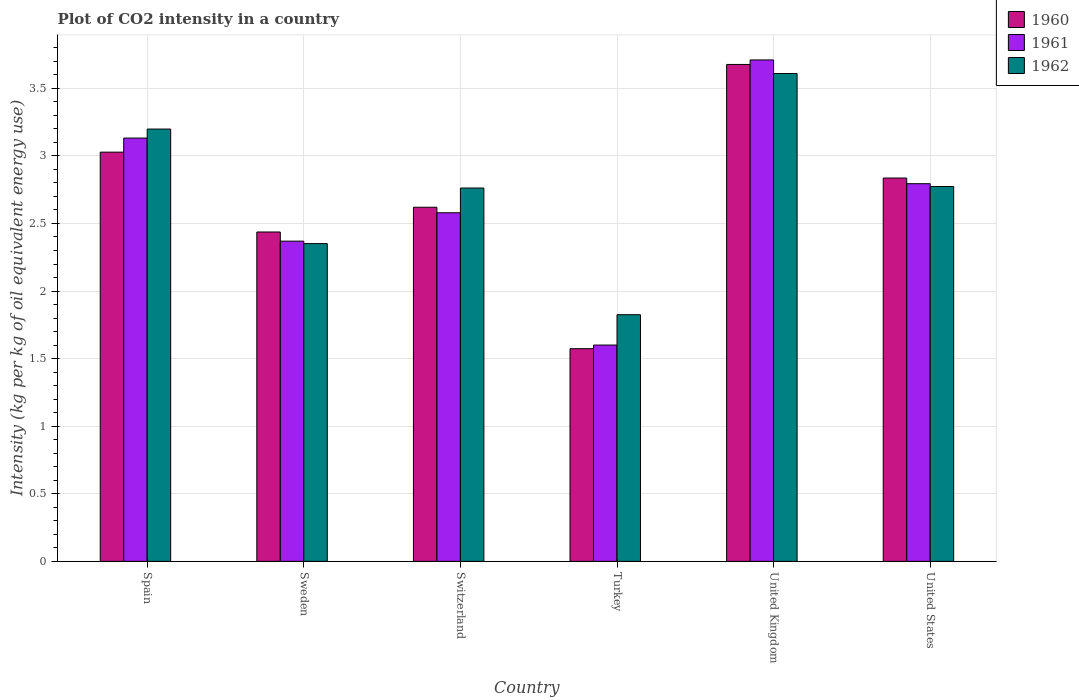How many bars are there on the 1st tick from the left?
Give a very brief answer. 3. What is the CO2 intensity in in 1961 in Spain?
Make the answer very short. 3.13. Across all countries, what is the maximum CO2 intensity in in 1960?
Give a very brief answer. 3.68. Across all countries, what is the minimum CO2 intensity in in 1960?
Your response must be concise. 1.57. What is the total CO2 intensity in in 1960 in the graph?
Provide a short and direct response. 16.17. What is the difference between the CO2 intensity in in 1960 in Turkey and that in United States?
Offer a terse response. -1.26. What is the difference between the CO2 intensity in in 1960 in United Kingdom and the CO2 intensity in in 1962 in Turkey?
Give a very brief answer. 1.85. What is the average CO2 intensity in in 1960 per country?
Provide a short and direct response. 2.7. What is the difference between the CO2 intensity in of/in 1961 and CO2 intensity in of/in 1960 in Sweden?
Your answer should be compact. -0.07. What is the ratio of the CO2 intensity in in 1961 in Switzerland to that in United Kingdom?
Your response must be concise. 0.7. Is the CO2 intensity in in 1960 in Sweden less than that in Turkey?
Provide a short and direct response. No. What is the difference between the highest and the second highest CO2 intensity in in 1962?
Provide a short and direct response. 0.43. What is the difference between the highest and the lowest CO2 intensity in in 1962?
Provide a succinct answer. 1.78. What does the 3rd bar from the left in Spain represents?
Give a very brief answer. 1962. What does the 2nd bar from the right in Turkey represents?
Your answer should be very brief. 1961. Is it the case that in every country, the sum of the CO2 intensity in in 1960 and CO2 intensity in in 1961 is greater than the CO2 intensity in in 1962?
Your response must be concise. Yes. How many bars are there?
Your response must be concise. 18. What is the difference between two consecutive major ticks on the Y-axis?
Give a very brief answer. 0.5. Are the values on the major ticks of Y-axis written in scientific E-notation?
Ensure brevity in your answer.  No. Does the graph contain grids?
Make the answer very short. Yes. Where does the legend appear in the graph?
Your answer should be very brief. Top right. What is the title of the graph?
Your answer should be very brief. Plot of CO2 intensity in a country. Does "2006" appear as one of the legend labels in the graph?
Provide a succinct answer. No. What is the label or title of the X-axis?
Give a very brief answer. Country. What is the label or title of the Y-axis?
Offer a terse response. Intensity (kg per kg of oil equivalent energy use). What is the Intensity (kg per kg of oil equivalent energy use) in 1960 in Spain?
Your answer should be very brief. 3.03. What is the Intensity (kg per kg of oil equivalent energy use) in 1961 in Spain?
Your response must be concise. 3.13. What is the Intensity (kg per kg of oil equivalent energy use) in 1962 in Spain?
Make the answer very short. 3.2. What is the Intensity (kg per kg of oil equivalent energy use) of 1960 in Sweden?
Make the answer very short. 2.44. What is the Intensity (kg per kg of oil equivalent energy use) in 1961 in Sweden?
Keep it short and to the point. 2.37. What is the Intensity (kg per kg of oil equivalent energy use) of 1962 in Sweden?
Make the answer very short. 2.35. What is the Intensity (kg per kg of oil equivalent energy use) in 1960 in Switzerland?
Ensure brevity in your answer.  2.62. What is the Intensity (kg per kg of oil equivalent energy use) of 1961 in Switzerland?
Your response must be concise. 2.58. What is the Intensity (kg per kg of oil equivalent energy use) of 1962 in Switzerland?
Your response must be concise. 2.76. What is the Intensity (kg per kg of oil equivalent energy use) in 1960 in Turkey?
Give a very brief answer. 1.57. What is the Intensity (kg per kg of oil equivalent energy use) in 1961 in Turkey?
Ensure brevity in your answer.  1.6. What is the Intensity (kg per kg of oil equivalent energy use) of 1962 in Turkey?
Provide a succinct answer. 1.82. What is the Intensity (kg per kg of oil equivalent energy use) of 1960 in United Kingdom?
Make the answer very short. 3.68. What is the Intensity (kg per kg of oil equivalent energy use) in 1961 in United Kingdom?
Provide a short and direct response. 3.71. What is the Intensity (kg per kg of oil equivalent energy use) of 1962 in United Kingdom?
Provide a short and direct response. 3.61. What is the Intensity (kg per kg of oil equivalent energy use) in 1960 in United States?
Provide a short and direct response. 2.84. What is the Intensity (kg per kg of oil equivalent energy use) in 1961 in United States?
Keep it short and to the point. 2.79. What is the Intensity (kg per kg of oil equivalent energy use) of 1962 in United States?
Offer a terse response. 2.77. Across all countries, what is the maximum Intensity (kg per kg of oil equivalent energy use) of 1960?
Your answer should be very brief. 3.68. Across all countries, what is the maximum Intensity (kg per kg of oil equivalent energy use) of 1961?
Your answer should be compact. 3.71. Across all countries, what is the maximum Intensity (kg per kg of oil equivalent energy use) in 1962?
Provide a short and direct response. 3.61. Across all countries, what is the minimum Intensity (kg per kg of oil equivalent energy use) of 1960?
Provide a succinct answer. 1.57. Across all countries, what is the minimum Intensity (kg per kg of oil equivalent energy use) in 1961?
Make the answer very short. 1.6. Across all countries, what is the minimum Intensity (kg per kg of oil equivalent energy use) of 1962?
Your response must be concise. 1.82. What is the total Intensity (kg per kg of oil equivalent energy use) of 1960 in the graph?
Keep it short and to the point. 16.17. What is the total Intensity (kg per kg of oil equivalent energy use) of 1961 in the graph?
Ensure brevity in your answer.  16.18. What is the total Intensity (kg per kg of oil equivalent energy use) in 1962 in the graph?
Ensure brevity in your answer.  16.52. What is the difference between the Intensity (kg per kg of oil equivalent energy use) of 1960 in Spain and that in Sweden?
Ensure brevity in your answer.  0.59. What is the difference between the Intensity (kg per kg of oil equivalent energy use) of 1961 in Spain and that in Sweden?
Your response must be concise. 0.76. What is the difference between the Intensity (kg per kg of oil equivalent energy use) in 1962 in Spain and that in Sweden?
Offer a very short reply. 0.85. What is the difference between the Intensity (kg per kg of oil equivalent energy use) in 1960 in Spain and that in Switzerland?
Your response must be concise. 0.41. What is the difference between the Intensity (kg per kg of oil equivalent energy use) in 1961 in Spain and that in Switzerland?
Your response must be concise. 0.55. What is the difference between the Intensity (kg per kg of oil equivalent energy use) in 1962 in Spain and that in Switzerland?
Your answer should be compact. 0.44. What is the difference between the Intensity (kg per kg of oil equivalent energy use) in 1960 in Spain and that in Turkey?
Your answer should be very brief. 1.45. What is the difference between the Intensity (kg per kg of oil equivalent energy use) of 1961 in Spain and that in Turkey?
Keep it short and to the point. 1.53. What is the difference between the Intensity (kg per kg of oil equivalent energy use) of 1962 in Spain and that in Turkey?
Your answer should be compact. 1.37. What is the difference between the Intensity (kg per kg of oil equivalent energy use) in 1960 in Spain and that in United Kingdom?
Offer a terse response. -0.65. What is the difference between the Intensity (kg per kg of oil equivalent energy use) of 1961 in Spain and that in United Kingdom?
Your answer should be compact. -0.58. What is the difference between the Intensity (kg per kg of oil equivalent energy use) in 1962 in Spain and that in United Kingdom?
Provide a succinct answer. -0.41. What is the difference between the Intensity (kg per kg of oil equivalent energy use) in 1960 in Spain and that in United States?
Offer a terse response. 0.19. What is the difference between the Intensity (kg per kg of oil equivalent energy use) of 1961 in Spain and that in United States?
Keep it short and to the point. 0.34. What is the difference between the Intensity (kg per kg of oil equivalent energy use) of 1962 in Spain and that in United States?
Make the answer very short. 0.43. What is the difference between the Intensity (kg per kg of oil equivalent energy use) of 1960 in Sweden and that in Switzerland?
Offer a very short reply. -0.18. What is the difference between the Intensity (kg per kg of oil equivalent energy use) in 1961 in Sweden and that in Switzerland?
Give a very brief answer. -0.21. What is the difference between the Intensity (kg per kg of oil equivalent energy use) of 1962 in Sweden and that in Switzerland?
Offer a very short reply. -0.41. What is the difference between the Intensity (kg per kg of oil equivalent energy use) in 1960 in Sweden and that in Turkey?
Keep it short and to the point. 0.86. What is the difference between the Intensity (kg per kg of oil equivalent energy use) of 1961 in Sweden and that in Turkey?
Your response must be concise. 0.77. What is the difference between the Intensity (kg per kg of oil equivalent energy use) in 1962 in Sweden and that in Turkey?
Offer a very short reply. 0.53. What is the difference between the Intensity (kg per kg of oil equivalent energy use) of 1960 in Sweden and that in United Kingdom?
Keep it short and to the point. -1.24. What is the difference between the Intensity (kg per kg of oil equivalent energy use) in 1961 in Sweden and that in United Kingdom?
Give a very brief answer. -1.34. What is the difference between the Intensity (kg per kg of oil equivalent energy use) in 1962 in Sweden and that in United Kingdom?
Keep it short and to the point. -1.26. What is the difference between the Intensity (kg per kg of oil equivalent energy use) of 1960 in Sweden and that in United States?
Your answer should be very brief. -0.4. What is the difference between the Intensity (kg per kg of oil equivalent energy use) of 1961 in Sweden and that in United States?
Ensure brevity in your answer.  -0.43. What is the difference between the Intensity (kg per kg of oil equivalent energy use) in 1962 in Sweden and that in United States?
Keep it short and to the point. -0.42. What is the difference between the Intensity (kg per kg of oil equivalent energy use) of 1960 in Switzerland and that in Turkey?
Provide a succinct answer. 1.05. What is the difference between the Intensity (kg per kg of oil equivalent energy use) in 1961 in Switzerland and that in Turkey?
Keep it short and to the point. 0.98. What is the difference between the Intensity (kg per kg of oil equivalent energy use) of 1962 in Switzerland and that in Turkey?
Offer a terse response. 0.94. What is the difference between the Intensity (kg per kg of oil equivalent energy use) of 1960 in Switzerland and that in United Kingdom?
Keep it short and to the point. -1.06. What is the difference between the Intensity (kg per kg of oil equivalent energy use) in 1961 in Switzerland and that in United Kingdom?
Provide a succinct answer. -1.13. What is the difference between the Intensity (kg per kg of oil equivalent energy use) of 1962 in Switzerland and that in United Kingdom?
Give a very brief answer. -0.85. What is the difference between the Intensity (kg per kg of oil equivalent energy use) in 1960 in Switzerland and that in United States?
Provide a short and direct response. -0.22. What is the difference between the Intensity (kg per kg of oil equivalent energy use) of 1961 in Switzerland and that in United States?
Keep it short and to the point. -0.22. What is the difference between the Intensity (kg per kg of oil equivalent energy use) in 1962 in Switzerland and that in United States?
Ensure brevity in your answer.  -0.01. What is the difference between the Intensity (kg per kg of oil equivalent energy use) of 1960 in Turkey and that in United Kingdom?
Your answer should be compact. -2.1. What is the difference between the Intensity (kg per kg of oil equivalent energy use) of 1961 in Turkey and that in United Kingdom?
Give a very brief answer. -2.11. What is the difference between the Intensity (kg per kg of oil equivalent energy use) of 1962 in Turkey and that in United Kingdom?
Your response must be concise. -1.78. What is the difference between the Intensity (kg per kg of oil equivalent energy use) of 1960 in Turkey and that in United States?
Provide a succinct answer. -1.26. What is the difference between the Intensity (kg per kg of oil equivalent energy use) of 1961 in Turkey and that in United States?
Ensure brevity in your answer.  -1.19. What is the difference between the Intensity (kg per kg of oil equivalent energy use) of 1962 in Turkey and that in United States?
Keep it short and to the point. -0.95. What is the difference between the Intensity (kg per kg of oil equivalent energy use) of 1960 in United Kingdom and that in United States?
Provide a succinct answer. 0.84. What is the difference between the Intensity (kg per kg of oil equivalent energy use) in 1961 in United Kingdom and that in United States?
Provide a succinct answer. 0.92. What is the difference between the Intensity (kg per kg of oil equivalent energy use) of 1962 in United Kingdom and that in United States?
Your answer should be compact. 0.84. What is the difference between the Intensity (kg per kg of oil equivalent energy use) in 1960 in Spain and the Intensity (kg per kg of oil equivalent energy use) in 1961 in Sweden?
Offer a very short reply. 0.66. What is the difference between the Intensity (kg per kg of oil equivalent energy use) of 1960 in Spain and the Intensity (kg per kg of oil equivalent energy use) of 1962 in Sweden?
Make the answer very short. 0.68. What is the difference between the Intensity (kg per kg of oil equivalent energy use) of 1961 in Spain and the Intensity (kg per kg of oil equivalent energy use) of 1962 in Sweden?
Offer a very short reply. 0.78. What is the difference between the Intensity (kg per kg of oil equivalent energy use) in 1960 in Spain and the Intensity (kg per kg of oil equivalent energy use) in 1961 in Switzerland?
Offer a terse response. 0.45. What is the difference between the Intensity (kg per kg of oil equivalent energy use) in 1960 in Spain and the Intensity (kg per kg of oil equivalent energy use) in 1962 in Switzerland?
Offer a very short reply. 0.27. What is the difference between the Intensity (kg per kg of oil equivalent energy use) in 1961 in Spain and the Intensity (kg per kg of oil equivalent energy use) in 1962 in Switzerland?
Provide a short and direct response. 0.37. What is the difference between the Intensity (kg per kg of oil equivalent energy use) of 1960 in Spain and the Intensity (kg per kg of oil equivalent energy use) of 1961 in Turkey?
Your answer should be very brief. 1.43. What is the difference between the Intensity (kg per kg of oil equivalent energy use) of 1960 in Spain and the Intensity (kg per kg of oil equivalent energy use) of 1962 in Turkey?
Offer a very short reply. 1.2. What is the difference between the Intensity (kg per kg of oil equivalent energy use) of 1961 in Spain and the Intensity (kg per kg of oil equivalent energy use) of 1962 in Turkey?
Offer a terse response. 1.31. What is the difference between the Intensity (kg per kg of oil equivalent energy use) of 1960 in Spain and the Intensity (kg per kg of oil equivalent energy use) of 1961 in United Kingdom?
Keep it short and to the point. -0.68. What is the difference between the Intensity (kg per kg of oil equivalent energy use) of 1960 in Spain and the Intensity (kg per kg of oil equivalent energy use) of 1962 in United Kingdom?
Your answer should be very brief. -0.58. What is the difference between the Intensity (kg per kg of oil equivalent energy use) of 1961 in Spain and the Intensity (kg per kg of oil equivalent energy use) of 1962 in United Kingdom?
Offer a very short reply. -0.48. What is the difference between the Intensity (kg per kg of oil equivalent energy use) in 1960 in Spain and the Intensity (kg per kg of oil equivalent energy use) in 1961 in United States?
Offer a very short reply. 0.23. What is the difference between the Intensity (kg per kg of oil equivalent energy use) in 1960 in Spain and the Intensity (kg per kg of oil equivalent energy use) in 1962 in United States?
Your response must be concise. 0.25. What is the difference between the Intensity (kg per kg of oil equivalent energy use) in 1961 in Spain and the Intensity (kg per kg of oil equivalent energy use) in 1962 in United States?
Keep it short and to the point. 0.36. What is the difference between the Intensity (kg per kg of oil equivalent energy use) of 1960 in Sweden and the Intensity (kg per kg of oil equivalent energy use) of 1961 in Switzerland?
Offer a terse response. -0.14. What is the difference between the Intensity (kg per kg of oil equivalent energy use) of 1960 in Sweden and the Intensity (kg per kg of oil equivalent energy use) of 1962 in Switzerland?
Give a very brief answer. -0.33. What is the difference between the Intensity (kg per kg of oil equivalent energy use) of 1961 in Sweden and the Intensity (kg per kg of oil equivalent energy use) of 1962 in Switzerland?
Offer a terse response. -0.39. What is the difference between the Intensity (kg per kg of oil equivalent energy use) of 1960 in Sweden and the Intensity (kg per kg of oil equivalent energy use) of 1961 in Turkey?
Provide a succinct answer. 0.84. What is the difference between the Intensity (kg per kg of oil equivalent energy use) of 1960 in Sweden and the Intensity (kg per kg of oil equivalent energy use) of 1962 in Turkey?
Your answer should be compact. 0.61. What is the difference between the Intensity (kg per kg of oil equivalent energy use) of 1961 in Sweden and the Intensity (kg per kg of oil equivalent energy use) of 1962 in Turkey?
Ensure brevity in your answer.  0.54. What is the difference between the Intensity (kg per kg of oil equivalent energy use) of 1960 in Sweden and the Intensity (kg per kg of oil equivalent energy use) of 1961 in United Kingdom?
Provide a short and direct response. -1.27. What is the difference between the Intensity (kg per kg of oil equivalent energy use) in 1960 in Sweden and the Intensity (kg per kg of oil equivalent energy use) in 1962 in United Kingdom?
Ensure brevity in your answer.  -1.17. What is the difference between the Intensity (kg per kg of oil equivalent energy use) in 1961 in Sweden and the Intensity (kg per kg of oil equivalent energy use) in 1962 in United Kingdom?
Make the answer very short. -1.24. What is the difference between the Intensity (kg per kg of oil equivalent energy use) of 1960 in Sweden and the Intensity (kg per kg of oil equivalent energy use) of 1961 in United States?
Offer a very short reply. -0.36. What is the difference between the Intensity (kg per kg of oil equivalent energy use) in 1960 in Sweden and the Intensity (kg per kg of oil equivalent energy use) in 1962 in United States?
Your response must be concise. -0.34. What is the difference between the Intensity (kg per kg of oil equivalent energy use) in 1961 in Sweden and the Intensity (kg per kg of oil equivalent energy use) in 1962 in United States?
Ensure brevity in your answer.  -0.4. What is the difference between the Intensity (kg per kg of oil equivalent energy use) in 1960 in Switzerland and the Intensity (kg per kg of oil equivalent energy use) in 1961 in Turkey?
Your answer should be very brief. 1.02. What is the difference between the Intensity (kg per kg of oil equivalent energy use) of 1960 in Switzerland and the Intensity (kg per kg of oil equivalent energy use) of 1962 in Turkey?
Ensure brevity in your answer.  0.8. What is the difference between the Intensity (kg per kg of oil equivalent energy use) in 1961 in Switzerland and the Intensity (kg per kg of oil equivalent energy use) in 1962 in Turkey?
Your response must be concise. 0.75. What is the difference between the Intensity (kg per kg of oil equivalent energy use) of 1960 in Switzerland and the Intensity (kg per kg of oil equivalent energy use) of 1961 in United Kingdom?
Your answer should be compact. -1.09. What is the difference between the Intensity (kg per kg of oil equivalent energy use) in 1960 in Switzerland and the Intensity (kg per kg of oil equivalent energy use) in 1962 in United Kingdom?
Keep it short and to the point. -0.99. What is the difference between the Intensity (kg per kg of oil equivalent energy use) of 1961 in Switzerland and the Intensity (kg per kg of oil equivalent energy use) of 1962 in United Kingdom?
Provide a succinct answer. -1.03. What is the difference between the Intensity (kg per kg of oil equivalent energy use) of 1960 in Switzerland and the Intensity (kg per kg of oil equivalent energy use) of 1961 in United States?
Offer a very short reply. -0.17. What is the difference between the Intensity (kg per kg of oil equivalent energy use) in 1960 in Switzerland and the Intensity (kg per kg of oil equivalent energy use) in 1962 in United States?
Keep it short and to the point. -0.15. What is the difference between the Intensity (kg per kg of oil equivalent energy use) in 1961 in Switzerland and the Intensity (kg per kg of oil equivalent energy use) in 1962 in United States?
Provide a short and direct response. -0.19. What is the difference between the Intensity (kg per kg of oil equivalent energy use) of 1960 in Turkey and the Intensity (kg per kg of oil equivalent energy use) of 1961 in United Kingdom?
Offer a very short reply. -2.14. What is the difference between the Intensity (kg per kg of oil equivalent energy use) of 1960 in Turkey and the Intensity (kg per kg of oil equivalent energy use) of 1962 in United Kingdom?
Offer a very short reply. -2.04. What is the difference between the Intensity (kg per kg of oil equivalent energy use) of 1961 in Turkey and the Intensity (kg per kg of oil equivalent energy use) of 1962 in United Kingdom?
Keep it short and to the point. -2.01. What is the difference between the Intensity (kg per kg of oil equivalent energy use) in 1960 in Turkey and the Intensity (kg per kg of oil equivalent energy use) in 1961 in United States?
Provide a short and direct response. -1.22. What is the difference between the Intensity (kg per kg of oil equivalent energy use) in 1960 in Turkey and the Intensity (kg per kg of oil equivalent energy use) in 1962 in United States?
Keep it short and to the point. -1.2. What is the difference between the Intensity (kg per kg of oil equivalent energy use) of 1961 in Turkey and the Intensity (kg per kg of oil equivalent energy use) of 1962 in United States?
Offer a terse response. -1.17. What is the difference between the Intensity (kg per kg of oil equivalent energy use) in 1960 in United Kingdom and the Intensity (kg per kg of oil equivalent energy use) in 1961 in United States?
Keep it short and to the point. 0.88. What is the difference between the Intensity (kg per kg of oil equivalent energy use) of 1960 in United Kingdom and the Intensity (kg per kg of oil equivalent energy use) of 1962 in United States?
Provide a short and direct response. 0.9. What is the difference between the Intensity (kg per kg of oil equivalent energy use) of 1961 in United Kingdom and the Intensity (kg per kg of oil equivalent energy use) of 1962 in United States?
Your answer should be compact. 0.94. What is the average Intensity (kg per kg of oil equivalent energy use) of 1960 per country?
Provide a succinct answer. 2.69. What is the average Intensity (kg per kg of oil equivalent energy use) of 1961 per country?
Make the answer very short. 2.7. What is the average Intensity (kg per kg of oil equivalent energy use) in 1962 per country?
Keep it short and to the point. 2.75. What is the difference between the Intensity (kg per kg of oil equivalent energy use) of 1960 and Intensity (kg per kg of oil equivalent energy use) of 1961 in Spain?
Keep it short and to the point. -0.1. What is the difference between the Intensity (kg per kg of oil equivalent energy use) in 1960 and Intensity (kg per kg of oil equivalent energy use) in 1962 in Spain?
Make the answer very short. -0.17. What is the difference between the Intensity (kg per kg of oil equivalent energy use) in 1961 and Intensity (kg per kg of oil equivalent energy use) in 1962 in Spain?
Offer a very short reply. -0.07. What is the difference between the Intensity (kg per kg of oil equivalent energy use) in 1960 and Intensity (kg per kg of oil equivalent energy use) in 1961 in Sweden?
Provide a short and direct response. 0.07. What is the difference between the Intensity (kg per kg of oil equivalent energy use) of 1960 and Intensity (kg per kg of oil equivalent energy use) of 1962 in Sweden?
Your answer should be compact. 0.09. What is the difference between the Intensity (kg per kg of oil equivalent energy use) in 1961 and Intensity (kg per kg of oil equivalent energy use) in 1962 in Sweden?
Offer a very short reply. 0.02. What is the difference between the Intensity (kg per kg of oil equivalent energy use) in 1960 and Intensity (kg per kg of oil equivalent energy use) in 1961 in Switzerland?
Give a very brief answer. 0.04. What is the difference between the Intensity (kg per kg of oil equivalent energy use) in 1960 and Intensity (kg per kg of oil equivalent energy use) in 1962 in Switzerland?
Your answer should be very brief. -0.14. What is the difference between the Intensity (kg per kg of oil equivalent energy use) of 1961 and Intensity (kg per kg of oil equivalent energy use) of 1962 in Switzerland?
Give a very brief answer. -0.18. What is the difference between the Intensity (kg per kg of oil equivalent energy use) in 1960 and Intensity (kg per kg of oil equivalent energy use) in 1961 in Turkey?
Offer a very short reply. -0.03. What is the difference between the Intensity (kg per kg of oil equivalent energy use) of 1960 and Intensity (kg per kg of oil equivalent energy use) of 1962 in Turkey?
Provide a short and direct response. -0.25. What is the difference between the Intensity (kg per kg of oil equivalent energy use) of 1961 and Intensity (kg per kg of oil equivalent energy use) of 1962 in Turkey?
Offer a very short reply. -0.22. What is the difference between the Intensity (kg per kg of oil equivalent energy use) of 1960 and Intensity (kg per kg of oil equivalent energy use) of 1961 in United Kingdom?
Ensure brevity in your answer.  -0.03. What is the difference between the Intensity (kg per kg of oil equivalent energy use) in 1960 and Intensity (kg per kg of oil equivalent energy use) in 1962 in United Kingdom?
Your response must be concise. 0.07. What is the difference between the Intensity (kg per kg of oil equivalent energy use) in 1961 and Intensity (kg per kg of oil equivalent energy use) in 1962 in United Kingdom?
Give a very brief answer. 0.1. What is the difference between the Intensity (kg per kg of oil equivalent energy use) of 1960 and Intensity (kg per kg of oil equivalent energy use) of 1961 in United States?
Your answer should be compact. 0.04. What is the difference between the Intensity (kg per kg of oil equivalent energy use) in 1960 and Intensity (kg per kg of oil equivalent energy use) in 1962 in United States?
Offer a terse response. 0.06. What is the difference between the Intensity (kg per kg of oil equivalent energy use) of 1961 and Intensity (kg per kg of oil equivalent energy use) of 1962 in United States?
Ensure brevity in your answer.  0.02. What is the ratio of the Intensity (kg per kg of oil equivalent energy use) in 1960 in Spain to that in Sweden?
Ensure brevity in your answer.  1.24. What is the ratio of the Intensity (kg per kg of oil equivalent energy use) of 1961 in Spain to that in Sweden?
Offer a very short reply. 1.32. What is the ratio of the Intensity (kg per kg of oil equivalent energy use) of 1962 in Spain to that in Sweden?
Your answer should be compact. 1.36. What is the ratio of the Intensity (kg per kg of oil equivalent energy use) in 1960 in Spain to that in Switzerland?
Keep it short and to the point. 1.16. What is the ratio of the Intensity (kg per kg of oil equivalent energy use) in 1961 in Spain to that in Switzerland?
Your response must be concise. 1.21. What is the ratio of the Intensity (kg per kg of oil equivalent energy use) of 1962 in Spain to that in Switzerland?
Your answer should be compact. 1.16. What is the ratio of the Intensity (kg per kg of oil equivalent energy use) in 1960 in Spain to that in Turkey?
Provide a succinct answer. 1.92. What is the ratio of the Intensity (kg per kg of oil equivalent energy use) of 1961 in Spain to that in Turkey?
Give a very brief answer. 1.96. What is the ratio of the Intensity (kg per kg of oil equivalent energy use) of 1962 in Spain to that in Turkey?
Keep it short and to the point. 1.75. What is the ratio of the Intensity (kg per kg of oil equivalent energy use) of 1960 in Spain to that in United Kingdom?
Offer a very short reply. 0.82. What is the ratio of the Intensity (kg per kg of oil equivalent energy use) in 1961 in Spain to that in United Kingdom?
Your answer should be compact. 0.84. What is the ratio of the Intensity (kg per kg of oil equivalent energy use) of 1962 in Spain to that in United Kingdom?
Give a very brief answer. 0.89. What is the ratio of the Intensity (kg per kg of oil equivalent energy use) in 1960 in Spain to that in United States?
Your answer should be very brief. 1.07. What is the ratio of the Intensity (kg per kg of oil equivalent energy use) in 1961 in Spain to that in United States?
Give a very brief answer. 1.12. What is the ratio of the Intensity (kg per kg of oil equivalent energy use) of 1962 in Spain to that in United States?
Provide a succinct answer. 1.15. What is the ratio of the Intensity (kg per kg of oil equivalent energy use) of 1960 in Sweden to that in Switzerland?
Offer a terse response. 0.93. What is the ratio of the Intensity (kg per kg of oil equivalent energy use) of 1961 in Sweden to that in Switzerland?
Give a very brief answer. 0.92. What is the ratio of the Intensity (kg per kg of oil equivalent energy use) of 1962 in Sweden to that in Switzerland?
Offer a terse response. 0.85. What is the ratio of the Intensity (kg per kg of oil equivalent energy use) in 1960 in Sweden to that in Turkey?
Your answer should be very brief. 1.55. What is the ratio of the Intensity (kg per kg of oil equivalent energy use) of 1961 in Sweden to that in Turkey?
Offer a terse response. 1.48. What is the ratio of the Intensity (kg per kg of oil equivalent energy use) of 1962 in Sweden to that in Turkey?
Your response must be concise. 1.29. What is the ratio of the Intensity (kg per kg of oil equivalent energy use) in 1960 in Sweden to that in United Kingdom?
Your answer should be very brief. 0.66. What is the ratio of the Intensity (kg per kg of oil equivalent energy use) in 1961 in Sweden to that in United Kingdom?
Your answer should be compact. 0.64. What is the ratio of the Intensity (kg per kg of oil equivalent energy use) in 1962 in Sweden to that in United Kingdom?
Keep it short and to the point. 0.65. What is the ratio of the Intensity (kg per kg of oil equivalent energy use) of 1960 in Sweden to that in United States?
Offer a terse response. 0.86. What is the ratio of the Intensity (kg per kg of oil equivalent energy use) in 1961 in Sweden to that in United States?
Keep it short and to the point. 0.85. What is the ratio of the Intensity (kg per kg of oil equivalent energy use) in 1962 in Sweden to that in United States?
Give a very brief answer. 0.85. What is the ratio of the Intensity (kg per kg of oil equivalent energy use) in 1960 in Switzerland to that in Turkey?
Ensure brevity in your answer.  1.67. What is the ratio of the Intensity (kg per kg of oil equivalent energy use) of 1961 in Switzerland to that in Turkey?
Offer a terse response. 1.61. What is the ratio of the Intensity (kg per kg of oil equivalent energy use) of 1962 in Switzerland to that in Turkey?
Give a very brief answer. 1.51. What is the ratio of the Intensity (kg per kg of oil equivalent energy use) in 1960 in Switzerland to that in United Kingdom?
Your response must be concise. 0.71. What is the ratio of the Intensity (kg per kg of oil equivalent energy use) in 1961 in Switzerland to that in United Kingdom?
Offer a terse response. 0.7. What is the ratio of the Intensity (kg per kg of oil equivalent energy use) in 1962 in Switzerland to that in United Kingdom?
Keep it short and to the point. 0.77. What is the ratio of the Intensity (kg per kg of oil equivalent energy use) of 1960 in Switzerland to that in United States?
Your answer should be very brief. 0.92. What is the ratio of the Intensity (kg per kg of oil equivalent energy use) in 1961 in Switzerland to that in United States?
Your answer should be compact. 0.92. What is the ratio of the Intensity (kg per kg of oil equivalent energy use) in 1960 in Turkey to that in United Kingdom?
Your response must be concise. 0.43. What is the ratio of the Intensity (kg per kg of oil equivalent energy use) in 1961 in Turkey to that in United Kingdom?
Make the answer very short. 0.43. What is the ratio of the Intensity (kg per kg of oil equivalent energy use) of 1962 in Turkey to that in United Kingdom?
Make the answer very short. 0.51. What is the ratio of the Intensity (kg per kg of oil equivalent energy use) in 1960 in Turkey to that in United States?
Offer a terse response. 0.55. What is the ratio of the Intensity (kg per kg of oil equivalent energy use) of 1961 in Turkey to that in United States?
Ensure brevity in your answer.  0.57. What is the ratio of the Intensity (kg per kg of oil equivalent energy use) in 1962 in Turkey to that in United States?
Ensure brevity in your answer.  0.66. What is the ratio of the Intensity (kg per kg of oil equivalent energy use) of 1960 in United Kingdom to that in United States?
Keep it short and to the point. 1.3. What is the ratio of the Intensity (kg per kg of oil equivalent energy use) of 1961 in United Kingdom to that in United States?
Provide a succinct answer. 1.33. What is the ratio of the Intensity (kg per kg of oil equivalent energy use) of 1962 in United Kingdom to that in United States?
Provide a succinct answer. 1.3. What is the difference between the highest and the second highest Intensity (kg per kg of oil equivalent energy use) in 1960?
Provide a succinct answer. 0.65. What is the difference between the highest and the second highest Intensity (kg per kg of oil equivalent energy use) in 1961?
Give a very brief answer. 0.58. What is the difference between the highest and the second highest Intensity (kg per kg of oil equivalent energy use) in 1962?
Keep it short and to the point. 0.41. What is the difference between the highest and the lowest Intensity (kg per kg of oil equivalent energy use) in 1960?
Your response must be concise. 2.1. What is the difference between the highest and the lowest Intensity (kg per kg of oil equivalent energy use) in 1961?
Offer a terse response. 2.11. What is the difference between the highest and the lowest Intensity (kg per kg of oil equivalent energy use) of 1962?
Your response must be concise. 1.78. 